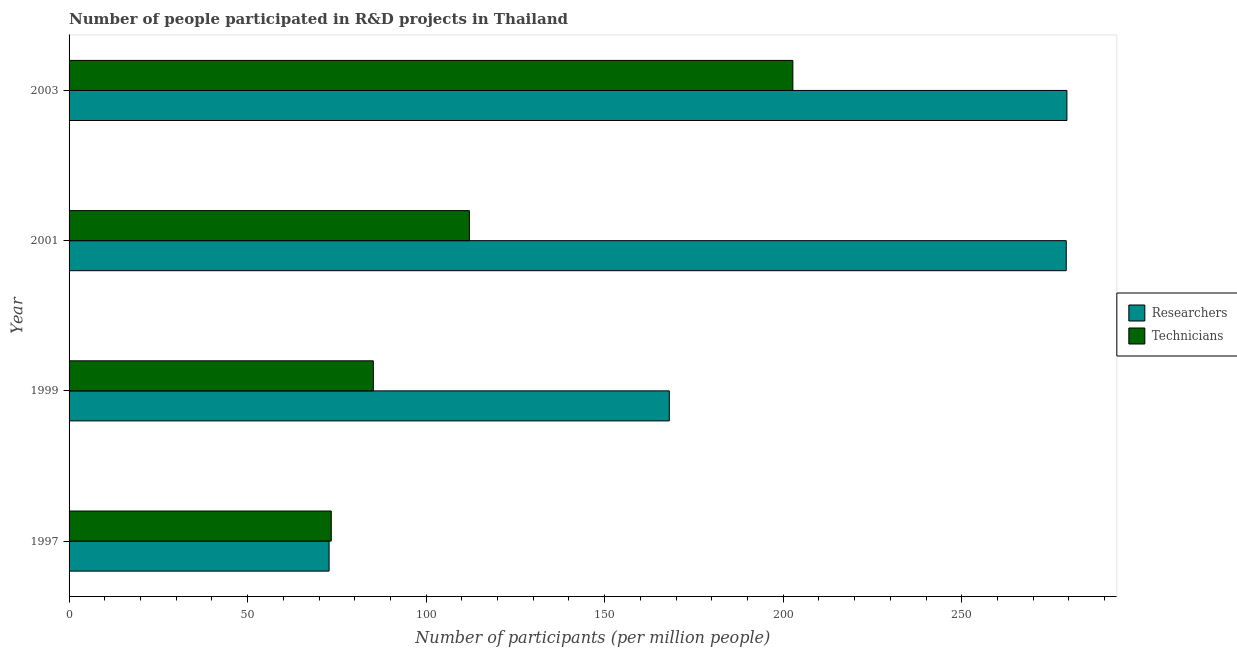Are the number of bars per tick equal to the number of legend labels?
Your answer should be very brief. Yes. How many bars are there on the 2nd tick from the top?
Provide a short and direct response. 2. How many bars are there on the 1st tick from the bottom?
Give a very brief answer. 2. What is the label of the 1st group of bars from the top?
Keep it short and to the point. 2003. What is the number of researchers in 1999?
Your answer should be compact. 168.1. Across all years, what is the maximum number of technicians?
Offer a very short reply. 202.71. Across all years, what is the minimum number of technicians?
Ensure brevity in your answer.  73.43. What is the total number of researchers in the graph?
Your answer should be compact. 799.66. What is the difference between the number of researchers in 2001 and that in 2003?
Give a very brief answer. -0.19. What is the difference between the number of technicians in 1997 and the number of researchers in 2001?
Your response must be concise. -205.84. What is the average number of researchers per year?
Your response must be concise. 199.91. In the year 1997, what is the difference between the number of technicians and number of researchers?
Your response must be concise. 0.61. In how many years, is the number of technicians greater than 80 ?
Offer a terse response. 3. What is the ratio of the number of researchers in 1997 to that in 2001?
Ensure brevity in your answer.  0.26. What is the difference between the highest and the second highest number of technicians?
Your response must be concise. 90.59. What is the difference between the highest and the lowest number of researchers?
Your answer should be compact. 206.64. In how many years, is the number of researchers greater than the average number of researchers taken over all years?
Offer a terse response. 2. Is the sum of the number of researchers in 1997 and 2003 greater than the maximum number of technicians across all years?
Offer a terse response. Yes. What does the 2nd bar from the top in 1999 represents?
Provide a short and direct response. Researchers. What does the 1st bar from the bottom in 2001 represents?
Your answer should be compact. Researchers. How many bars are there?
Your answer should be very brief. 8. Are all the bars in the graph horizontal?
Your answer should be very brief. Yes. How many years are there in the graph?
Offer a very short reply. 4. What is the difference between two consecutive major ticks on the X-axis?
Your answer should be compact. 50. Does the graph contain grids?
Ensure brevity in your answer.  No. Where does the legend appear in the graph?
Provide a short and direct response. Center right. What is the title of the graph?
Offer a very short reply. Number of people participated in R&D projects in Thailand. Does "Fraud firms" appear as one of the legend labels in the graph?
Offer a very short reply. No. What is the label or title of the X-axis?
Your response must be concise. Number of participants (per million people). What is the Number of participants (per million people) of Researchers in 1997?
Keep it short and to the point. 72.82. What is the Number of participants (per million people) of Technicians in 1997?
Make the answer very short. 73.43. What is the Number of participants (per million people) in Researchers in 1999?
Offer a very short reply. 168.1. What is the Number of participants (per million people) in Technicians in 1999?
Provide a short and direct response. 85.21. What is the Number of participants (per million people) of Researchers in 2001?
Offer a very short reply. 279.27. What is the Number of participants (per million people) in Technicians in 2001?
Provide a short and direct response. 112.12. What is the Number of participants (per million people) of Researchers in 2003?
Provide a succinct answer. 279.46. What is the Number of participants (per million people) in Technicians in 2003?
Your response must be concise. 202.71. Across all years, what is the maximum Number of participants (per million people) in Researchers?
Ensure brevity in your answer.  279.46. Across all years, what is the maximum Number of participants (per million people) of Technicians?
Make the answer very short. 202.71. Across all years, what is the minimum Number of participants (per million people) of Researchers?
Provide a succinct answer. 72.82. Across all years, what is the minimum Number of participants (per million people) of Technicians?
Offer a terse response. 73.43. What is the total Number of participants (per million people) in Researchers in the graph?
Offer a terse response. 799.66. What is the total Number of participants (per million people) in Technicians in the graph?
Your answer should be compact. 473.47. What is the difference between the Number of participants (per million people) in Researchers in 1997 and that in 1999?
Offer a very short reply. -95.28. What is the difference between the Number of participants (per million people) in Technicians in 1997 and that in 1999?
Ensure brevity in your answer.  -11.78. What is the difference between the Number of participants (per million people) in Researchers in 1997 and that in 2001?
Keep it short and to the point. -206.45. What is the difference between the Number of participants (per million people) of Technicians in 1997 and that in 2001?
Your answer should be very brief. -38.69. What is the difference between the Number of participants (per million people) of Researchers in 1997 and that in 2003?
Your answer should be very brief. -206.64. What is the difference between the Number of participants (per million people) in Technicians in 1997 and that in 2003?
Provide a succinct answer. -129.28. What is the difference between the Number of participants (per million people) of Researchers in 1999 and that in 2001?
Your answer should be compact. -111.17. What is the difference between the Number of participants (per million people) of Technicians in 1999 and that in 2001?
Provide a succinct answer. -26.91. What is the difference between the Number of participants (per million people) in Researchers in 1999 and that in 2003?
Provide a succinct answer. -111.36. What is the difference between the Number of participants (per million people) in Technicians in 1999 and that in 2003?
Provide a succinct answer. -117.5. What is the difference between the Number of participants (per million people) in Researchers in 2001 and that in 2003?
Keep it short and to the point. -0.19. What is the difference between the Number of participants (per million people) of Technicians in 2001 and that in 2003?
Your answer should be very brief. -90.59. What is the difference between the Number of participants (per million people) of Researchers in 1997 and the Number of participants (per million people) of Technicians in 1999?
Keep it short and to the point. -12.39. What is the difference between the Number of participants (per million people) in Researchers in 1997 and the Number of participants (per million people) in Technicians in 2001?
Keep it short and to the point. -39.3. What is the difference between the Number of participants (per million people) in Researchers in 1997 and the Number of participants (per million people) in Technicians in 2003?
Make the answer very short. -129.89. What is the difference between the Number of participants (per million people) of Researchers in 1999 and the Number of participants (per million people) of Technicians in 2001?
Ensure brevity in your answer.  55.98. What is the difference between the Number of participants (per million people) in Researchers in 1999 and the Number of participants (per million people) in Technicians in 2003?
Keep it short and to the point. -34.61. What is the difference between the Number of participants (per million people) of Researchers in 2001 and the Number of participants (per million people) of Technicians in 2003?
Your answer should be very brief. 76.56. What is the average Number of participants (per million people) in Researchers per year?
Ensure brevity in your answer.  199.91. What is the average Number of participants (per million people) in Technicians per year?
Provide a short and direct response. 118.37. In the year 1997, what is the difference between the Number of participants (per million people) in Researchers and Number of participants (per million people) in Technicians?
Offer a very short reply. -0.61. In the year 1999, what is the difference between the Number of participants (per million people) of Researchers and Number of participants (per million people) of Technicians?
Ensure brevity in your answer.  82.89. In the year 2001, what is the difference between the Number of participants (per million people) of Researchers and Number of participants (per million people) of Technicians?
Your response must be concise. 167.15. In the year 2003, what is the difference between the Number of participants (per million people) of Researchers and Number of participants (per million people) of Technicians?
Offer a terse response. 76.75. What is the ratio of the Number of participants (per million people) in Researchers in 1997 to that in 1999?
Offer a terse response. 0.43. What is the ratio of the Number of participants (per million people) in Technicians in 1997 to that in 1999?
Offer a terse response. 0.86. What is the ratio of the Number of participants (per million people) in Researchers in 1997 to that in 2001?
Your answer should be very brief. 0.26. What is the ratio of the Number of participants (per million people) of Technicians in 1997 to that in 2001?
Make the answer very short. 0.66. What is the ratio of the Number of participants (per million people) in Researchers in 1997 to that in 2003?
Keep it short and to the point. 0.26. What is the ratio of the Number of participants (per million people) in Technicians in 1997 to that in 2003?
Keep it short and to the point. 0.36. What is the ratio of the Number of participants (per million people) of Researchers in 1999 to that in 2001?
Your answer should be very brief. 0.6. What is the ratio of the Number of participants (per million people) in Technicians in 1999 to that in 2001?
Your response must be concise. 0.76. What is the ratio of the Number of participants (per million people) in Researchers in 1999 to that in 2003?
Keep it short and to the point. 0.6. What is the ratio of the Number of participants (per million people) of Technicians in 1999 to that in 2003?
Give a very brief answer. 0.42. What is the ratio of the Number of participants (per million people) in Technicians in 2001 to that in 2003?
Your answer should be very brief. 0.55. What is the difference between the highest and the second highest Number of participants (per million people) of Researchers?
Your answer should be compact. 0.19. What is the difference between the highest and the second highest Number of participants (per million people) of Technicians?
Give a very brief answer. 90.59. What is the difference between the highest and the lowest Number of participants (per million people) in Researchers?
Provide a short and direct response. 206.64. What is the difference between the highest and the lowest Number of participants (per million people) of Technicians?
Your answer should be very brief. 129.28. 